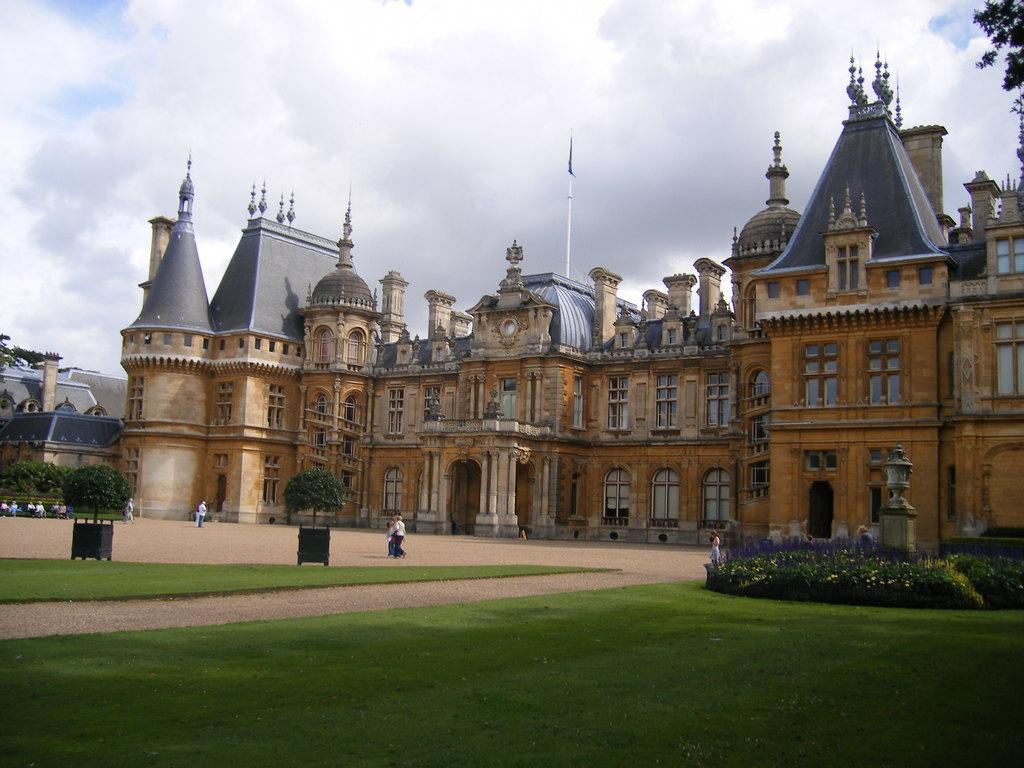Could you give a brief overview of what you see in this image? In this picture we can see building. At the top of the building we can see the domes, poles and flag. At the bottom we can see grass. On the right there is a woman who is standing near to the plant. In the center there is a group of persons were walking near to the bin. On the left we can see the group of person sitting on the bench. At the top we can see sky and clouds. In the top right corner there is a tree. 